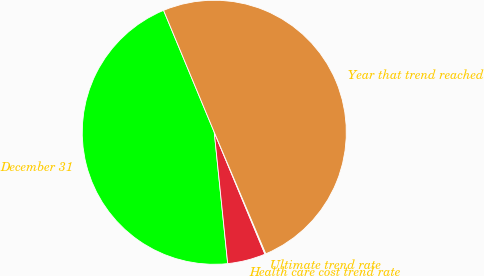Convert chart. <chart><loc_0><loc_0><loc_500><loc_500><pie_chart><fcel>December 31<fcel>Health care cost trend rate<fcel>Ultimate trend rate<fcel>Year that trend reached<nl><fcel>45.35%<fcel>4.65%<fcel>0.11%<fcel>49.89%<nl></chart> 